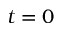Convert formula to latex. <formula><loc_0><loc_0><loc_500><loc_500>t = 0</formula> 